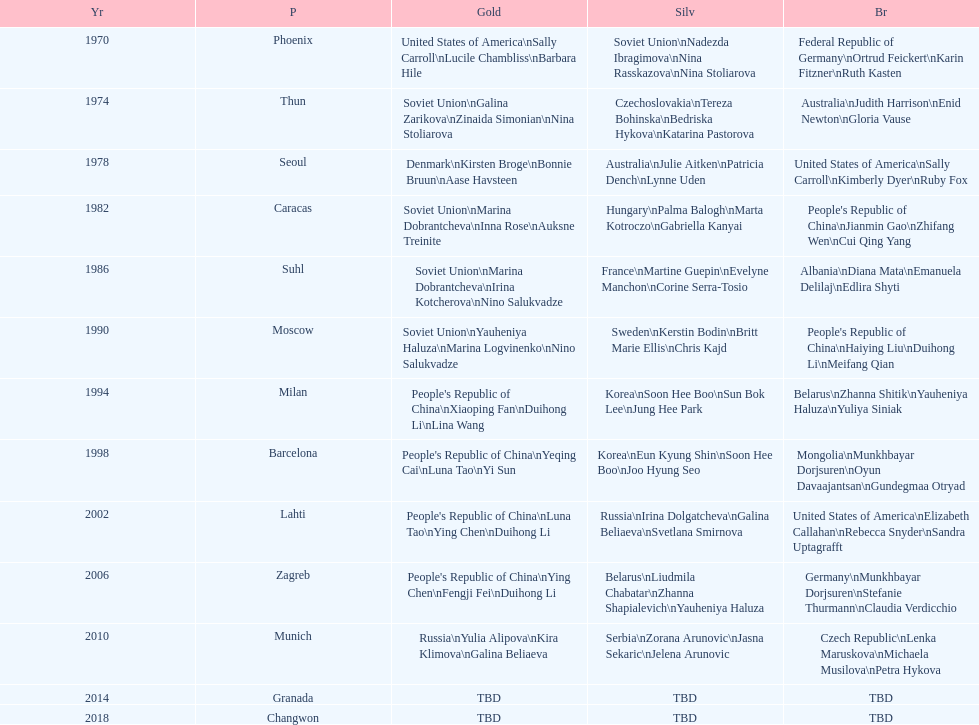Whose name is listed before bonnie bruun's in the gold column? Kirsten Broge. 